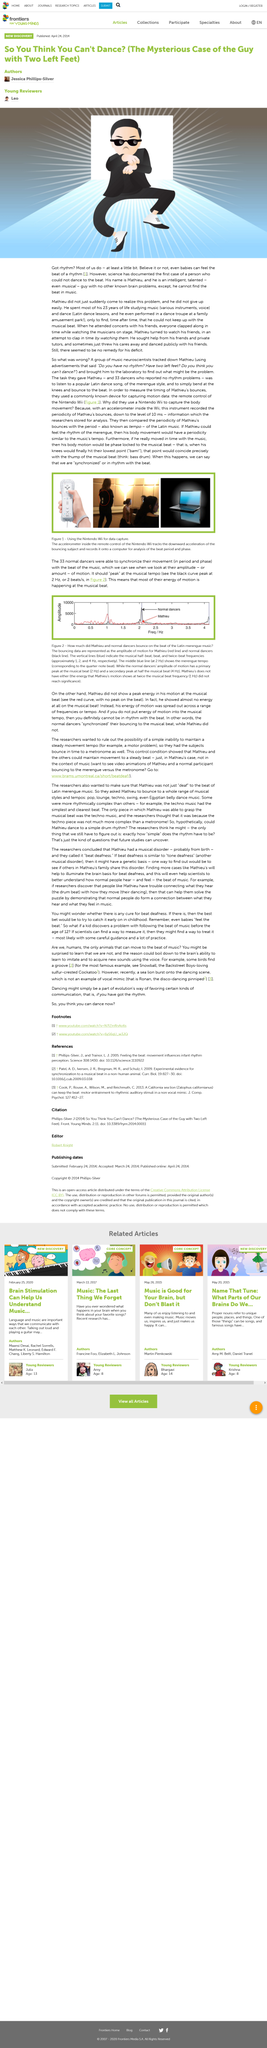Mention a couple of crucial points in this snapshot. It is scientifically established that not all humans possess the ability to feel rhythm, as evidenced by the existence of Mathieu, a person who lacks this ability. It is not possible for Mathieu to perform the described action in the picture, as he is unable to locate the rhythm of music. 